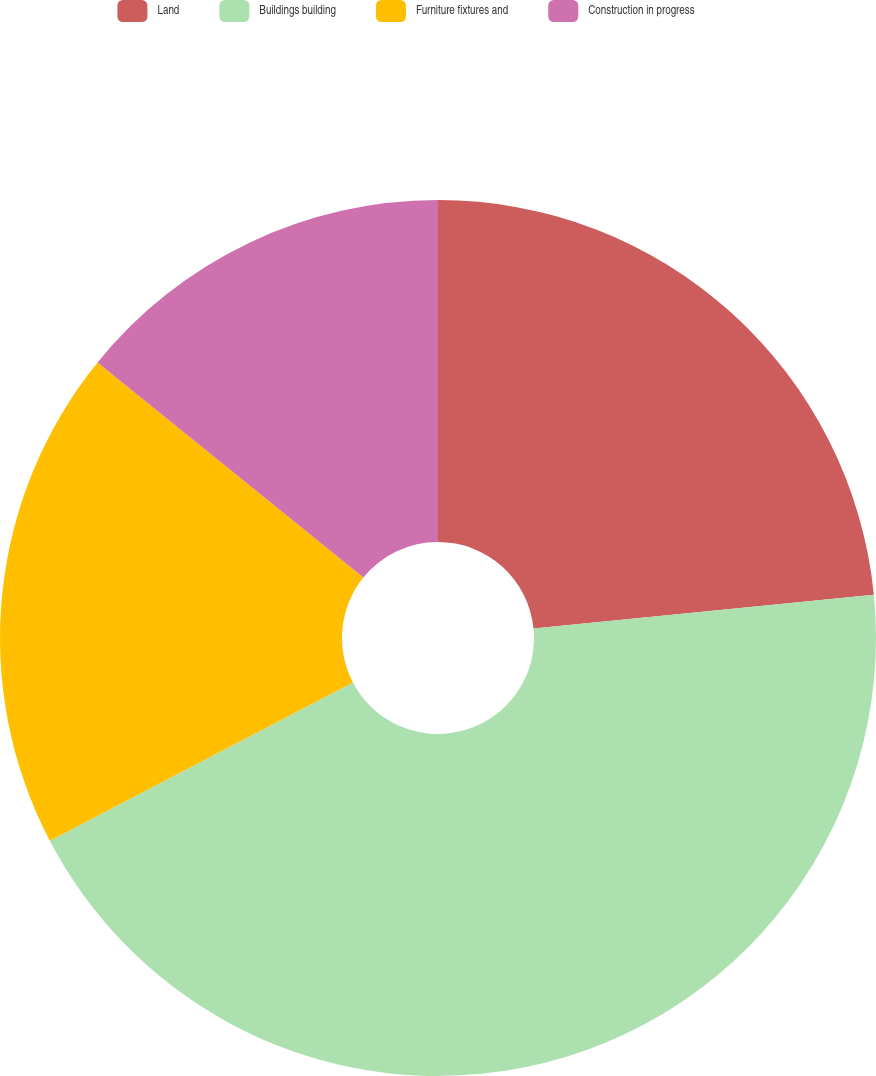Convert chart. <chart><loc_0><loc_0><loc_500><loc_500><pie_chart><fcel>Land<fcel>Buildings building<fcel>Furniture fixtures and<fcel>Construction in progress<nl><fcel>23.42%<fcel>43.91%<fcel>18.49%<fcel>14.17%<nl></chart> 